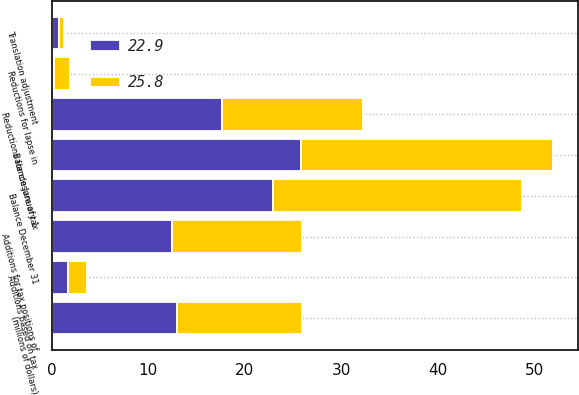Convert chart. <chart><loc_0><loc_0><loc_500><loc_500><stacked_bar_chart><ecel><fcel>(millions of dollars)<fcel>Balance January 1<fcel>Additions based on tax<fcel>Additions for tax positions of<fcel>Reductions for closure of tax<fcel>Reductions for lapse in<fcel>Translation adjustment<fcel>Balance December 31<nl><fcel>22.9<fcel>12.95<fcel>25.8<fcel>1.7<fcel>12.5<fcel>17.7<fcel>0.2<fcel>0.8<fcel>22.9<nl><fcel>25.8<fcel>12.95<fcel>26.2<fcel>2<fcel>13.4<fcel>14.6<fcel>1.7<fcel>0.5<fcel>25.8<nl></chart> 